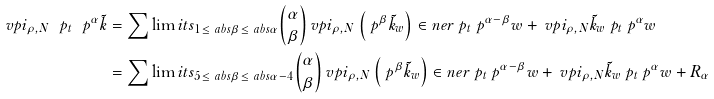<formula> <loc_0><loc_0><loc_500><loc_500>\ v p i _ { \rho , N } \ p _ { t } \ p ^ { \alpha } \tilde { k } & = \sum \lim i t s _ { 1 \leq \ a b s \beta \leq \ a b s \alpha } { \alpha \choose \beta } \ v p i _ { \rho , N } \left ( \ p ^ { \beta } \tilde { k } _ { w } \right ) \in n e r { \ p _ { t } \ p ^ { \alpha - \beta } w } + \ v p i _ { \rho , N } \tilde { k } _ { w } \ p _ { t } \ p ^ { \alpha } w \\ & = \sum \lim i t s _ { 5 \leq \ a b s \beta \leq \ a b s \alpha - 4 } { \alpha \choose \beta } \ v p i _ { \rho , N } \left ( \ p ^ { \beta } \tilde { k } _ { w } \right ) \in n e r { \ p _ { t } \ p ^ { \alpha - \beta } w } + \ v p i _ { \rho , N } \tilde { k } _ { w } \ p _ { t } \ p ^ { \alpha } w + R _ { \alpha }</formula> 